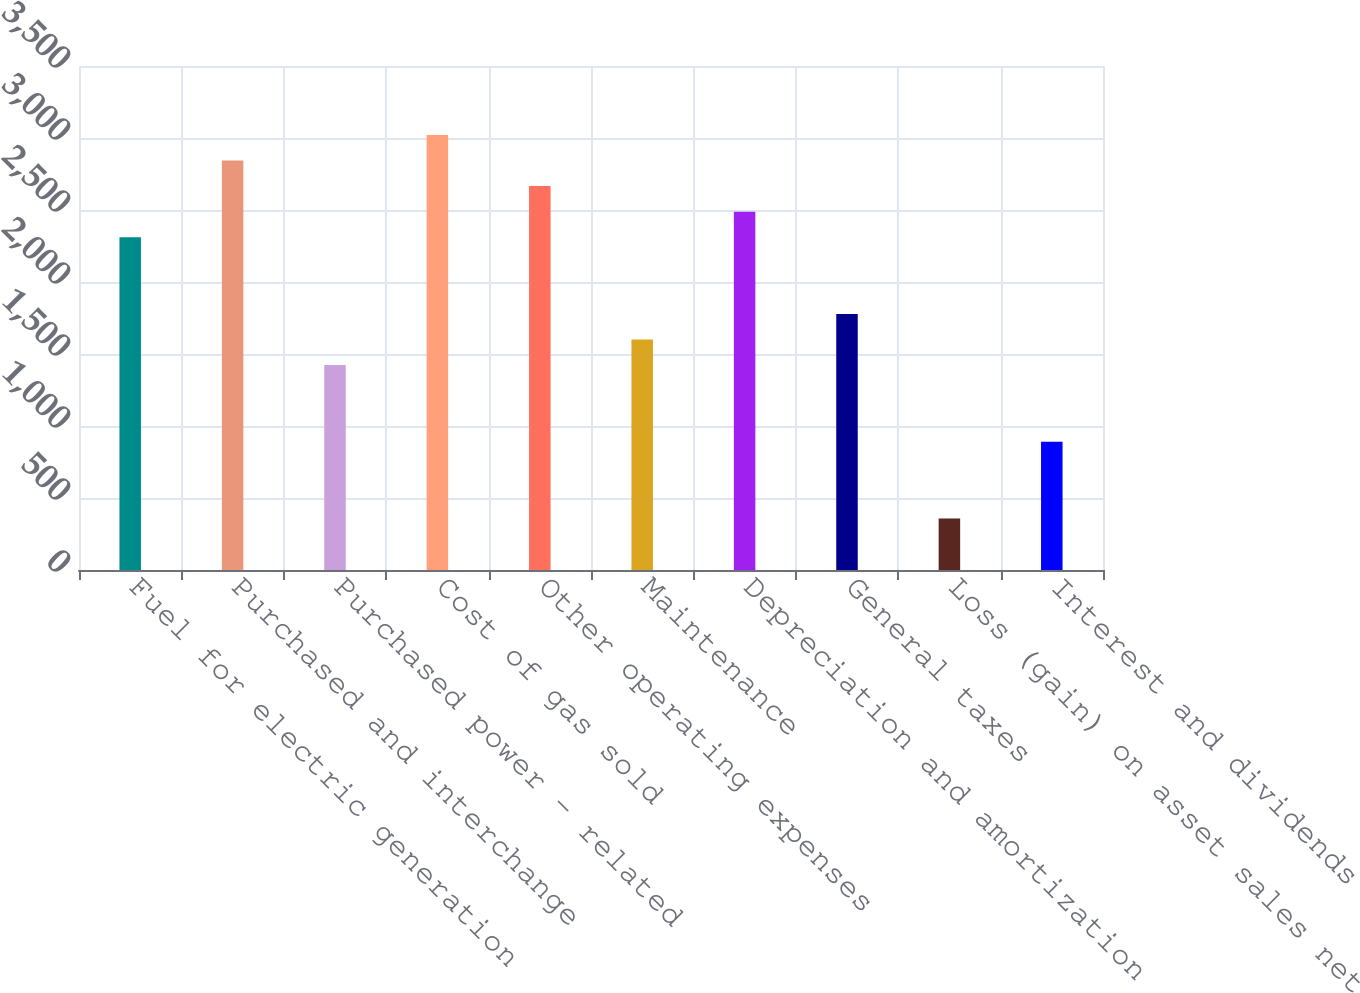<chart> <loc_0><loc_0><loc_500><loc_500><bar_chart><fcel>Fuel for electric generation<fcel>Purchased and interchange<fcel>Purchased power - related<fcel>Cost of gas sold<fcel>Other operating expenses<fcel>Maintenance<fcel>Depreciation and amortization<fcel>General taxes<fcel>Loss (gain) on asset sales net<fcel>Interest and dividends<nl><fcel>2310.8<fcel>2843.6<fcel>1422.8<fcel>3021.2<fcel>2666<fcel>1600.4<fcel>2488.4<fcel>1778<fcel>357.2<fcel>890<nl></chart> 